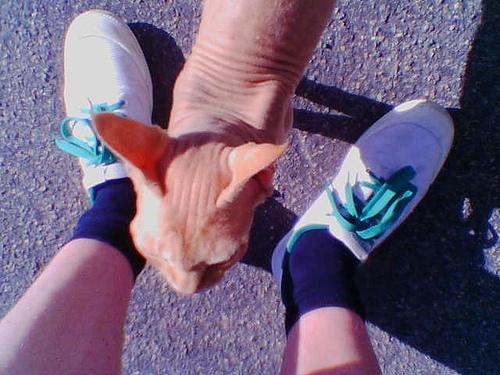Is this person wearing long pants?
Answer briefly. No. Does this animal have fur?
Concise answer only. No. Are the shoe strings tied?
Answer briefly. Yes. 